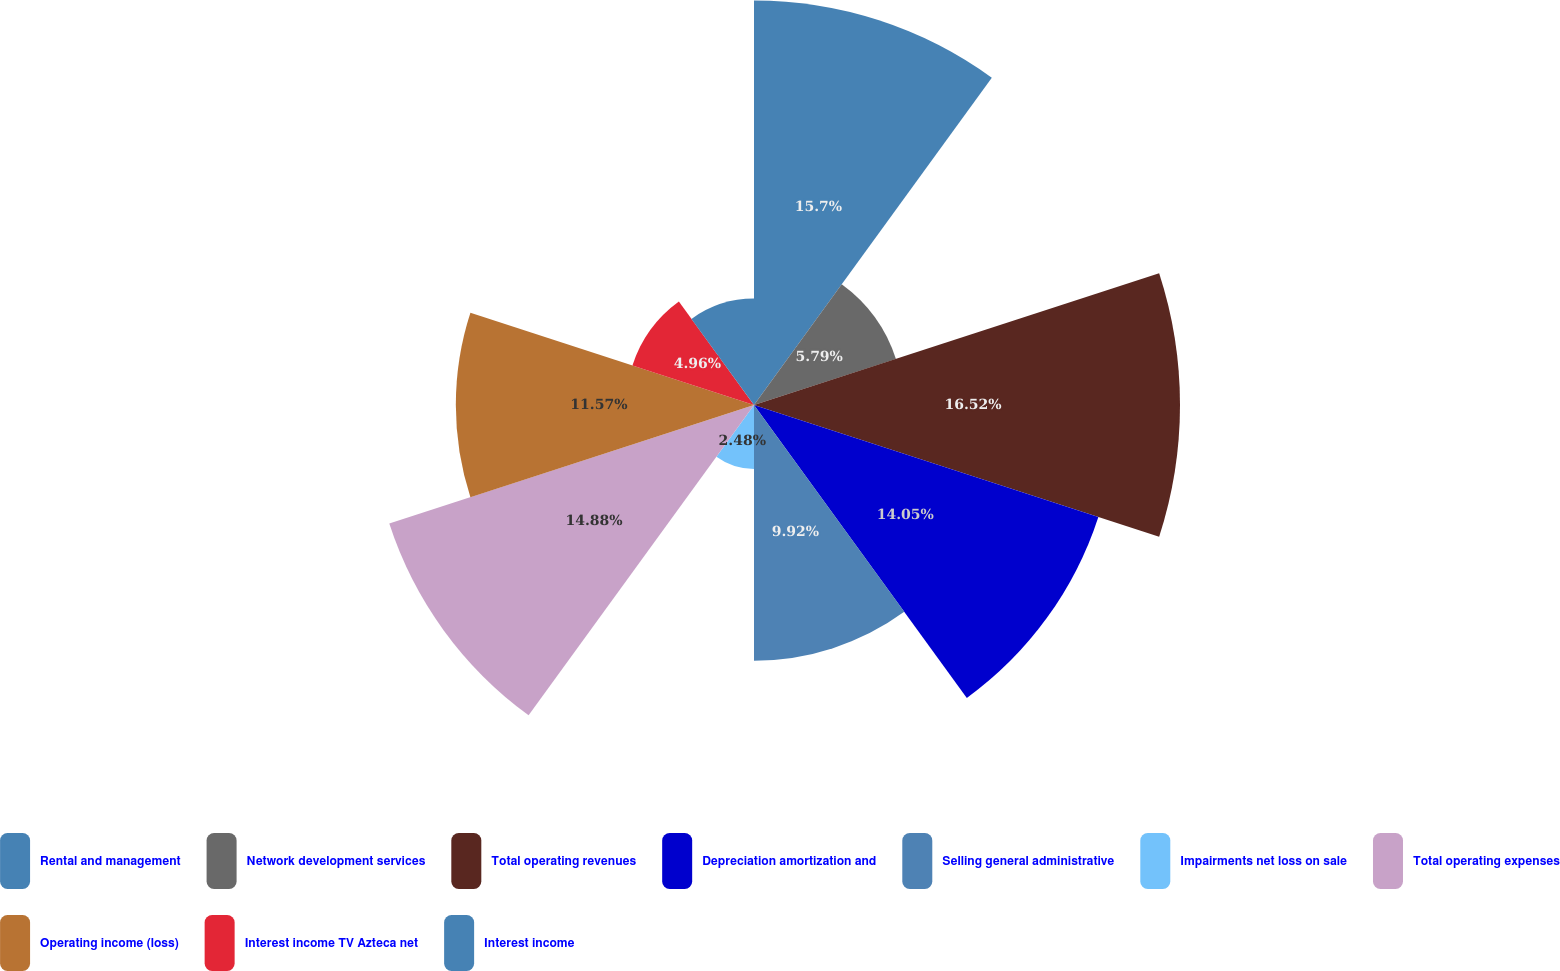Convert chart. <chart><loc_0><loc_0><loc_500><loc_500><pie_chart><fcel>Rental and management<fcel>Network development services<fcel>Total operating revenues<fcel>Depreciation amortization and<fcel>Selling general administrative<fcel>Impairments net loss on sale<fcel>Total operating expenses<fcel>Operating income (loss)<fcel>Interest income TV Azteca net<fcel>Interest income<nl><fcel>15.7%<fcel>5.79%<fcel>16.53%<fcel>14.05%<fcel>9.92%<fcel>2.48%<fcel>14.88%<fcel>11.57%<fcel>4.96%<fcel>4.13%<nl></chart> 